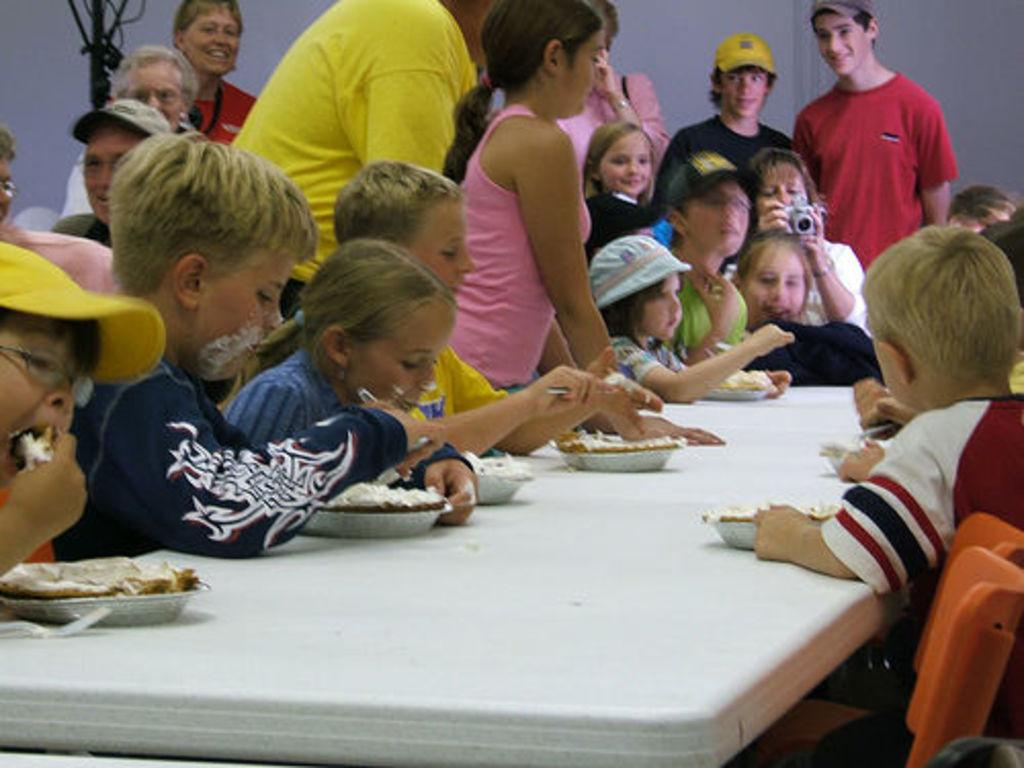What is the main subject of the image? The main subject of the image is kids on either side of a table. Can you describe the setting of the image? The kids are seated at a table, and there are people standing in the background of the image. What type of insurance policy is being discussed by the kids in the image? There is no indication in the image that the kids are discussing insurance policies. 